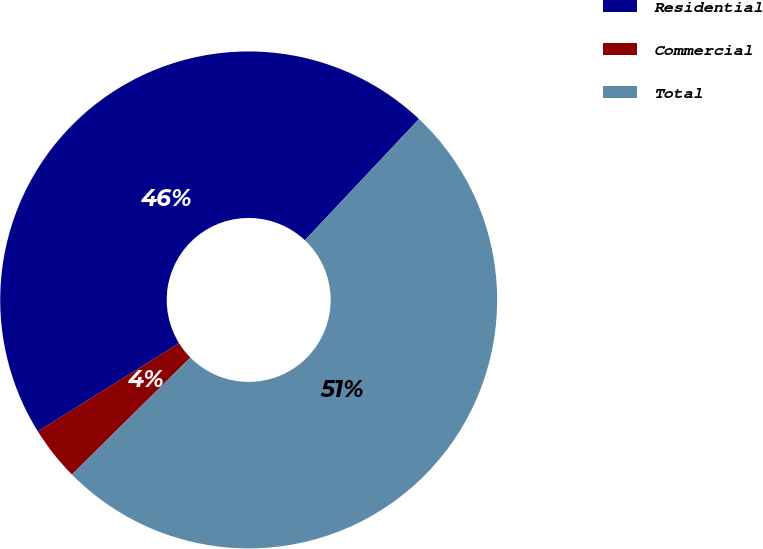Convert chart to OTSL. <chart><loc_0><loc_0><loc_500><loc_500><pie_chart><fcel>Residential<fcel>Commercial<fcel>Total<nl><fcel>45.89%<fcel>3.53%<fcel>50.58%<nl></chart> 